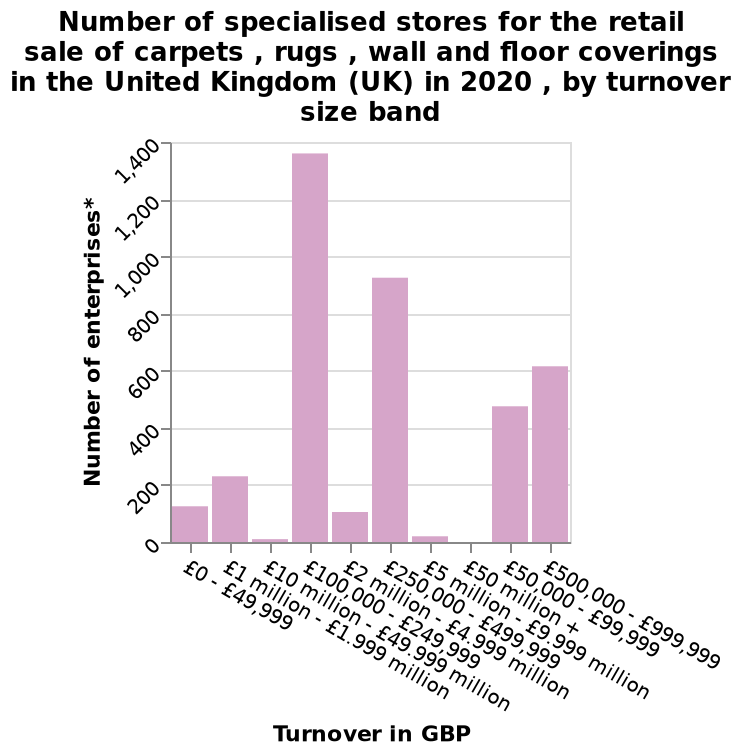<image>
What is the turnover range for the largest number of stores in the UK? The turnover range for the largest number of stores in the UK is between 100 million and 250 million. What is the range of the x-axis in the bar diagram?  The range of the x-axis in the bar diagram is from £0 - £49,999 to £500,000 - £999,999. 